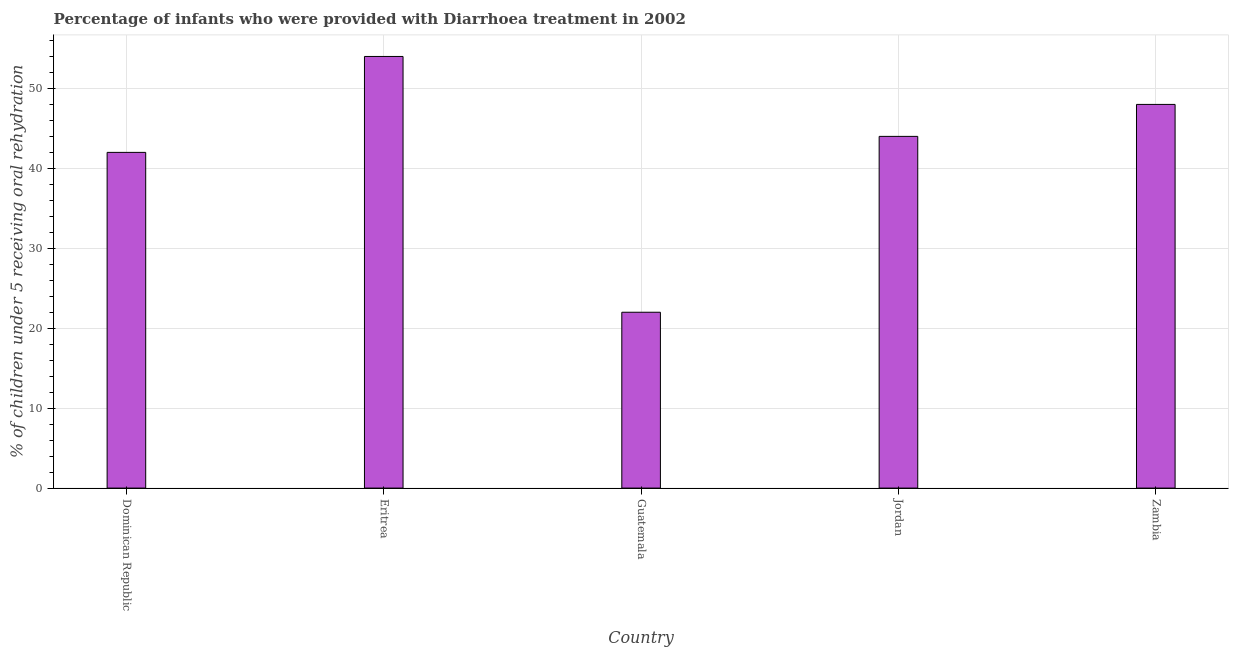Does the graph contain any zero values?
Give a very brief answer. No. Does the graph contain grids?
Your response must be concise. Yes. What is the title of the graph?
Give a very brief answer. Percentage of infants who were provided with Diarrhoea treatment in 2002. What is the label or title of the Y-axis?
Your answer should be compact. % of children under 5 receiving oral rehydration. What is the percentage of children who were provided with treatment diarrhoea in Guatemala?
Keep it short and to the point. 22. Across all countries, what is the maximum percentage of children who were provided with treatment diarrhoea?
Make the answer very short. 54. Across all countries, what is the minimum percentage of children who were provided with treatment diarrhoea?
Your answer should be compact. 22. In which country was the percentage of children who were provided with treatment diarrhoea maximum?
Make the answer very short. Eritrea. In which country was the percentage of children who were provided with treatment diarrhoea minimum?
Offer a very short reply. Guatemala. What is the sum of the percentage of children who were provided with treatment diarrhoea?
Provide a succinct answer. 210. What is the ratio of the percentage of children who were provided with treatment diarrhoea in Eritrea to that in Jordan?
Your response must be concise. 1.23. Is the sum of the percentage of children who were provided with treatment diarrhoea in Eritrea and Guatemala greater than the maximum percentage of children who were provided with treatment diarrhoea across all countries?
Make the answer very short. Yes. In how many countries, is the percentage of children who were provided with treatment diarrhoea greater than the average percentage of children who were provided with treatment diarrhoea taken over all countries?
Provide a short and direct response. 3. How many countries are there in the graph?
Offer a very short reply. 5. Are the values on the major ticks of Y-axis written in scientific E-notation?
Offer a very short reply. No. What is the % of children under 5 receiving oral rehydration of Guatemala?
Your answer should be very brief. 22. What is the % of children under 5 receiving oral rehydration of Zambia?
Offer a terse response. 48. What is the difference between the % of children under 5 receiving oral rehydration in Dominican Republic and Zambia?
Your answer should be compact. -6. What is the difference between the % of children under 5 receiving oral rehydration in Guatemala and Zambia?
Offer a very short reply. -26. What is the ratio of the % of children under 5 receiving oral rehydration in Dominican Republic to that in Eritrea?
Make the answer very short. 0.78. What is the ratio of the % of children under 5 receiving oral rehydration in Dominican Republic to that in Guatemala?
Make the answer very short. 1.91. What is the ratio of the % of children under 5 receiving oral rehydration in Dominican Republic to that in Jordan?
Ensure brevity in your answer.  0.95. What is the ratio of the % of children under 5 receiving oral rehydration in Eritrea to that in Guatemala?
Ensure brevity in your answer.  2.46. What is the ratio of the % of children under 5 receiving oral rehydration in Eritrea to that in Jordan?
Your response must be concise. 1.23. What is the ratio of the % of children under 5 receiving oral rehydration in Eritrea to that in Zambia?
Offer a terse response. 1.12. What is the ratio of the % of children under 5 receiving oral rehydration in Guatemala to that in Zambia?
Your answer should be compact. 0.46. What is the ratio of the % of children under 5 receiving oral rehydration in Jordan to that in Zambia?
Your answer should be very brief. 0.92. 